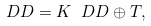Convert formula to latex. <formula><loc_0><loc_0><loc_500><loc_500>\ D D = K _ { \ } D D \oplus T ,</formula> 